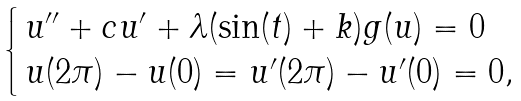Convert formula to latex. <formula><loc_0><loc_0><loc_500><loc_500>\begin{cases} \, u ^ { \prime \prime } + c u ^ { \prime } + \lambda ( \sin ( t ) + k ) g ( u ) = 0 \\ \, u ( 2 \pi ) - u ( 0 ) = u ^ { \prime } ( 2 \pi ) - u ^ { \prime } ( 0 ) = 0 , \end{cases}</formula> 